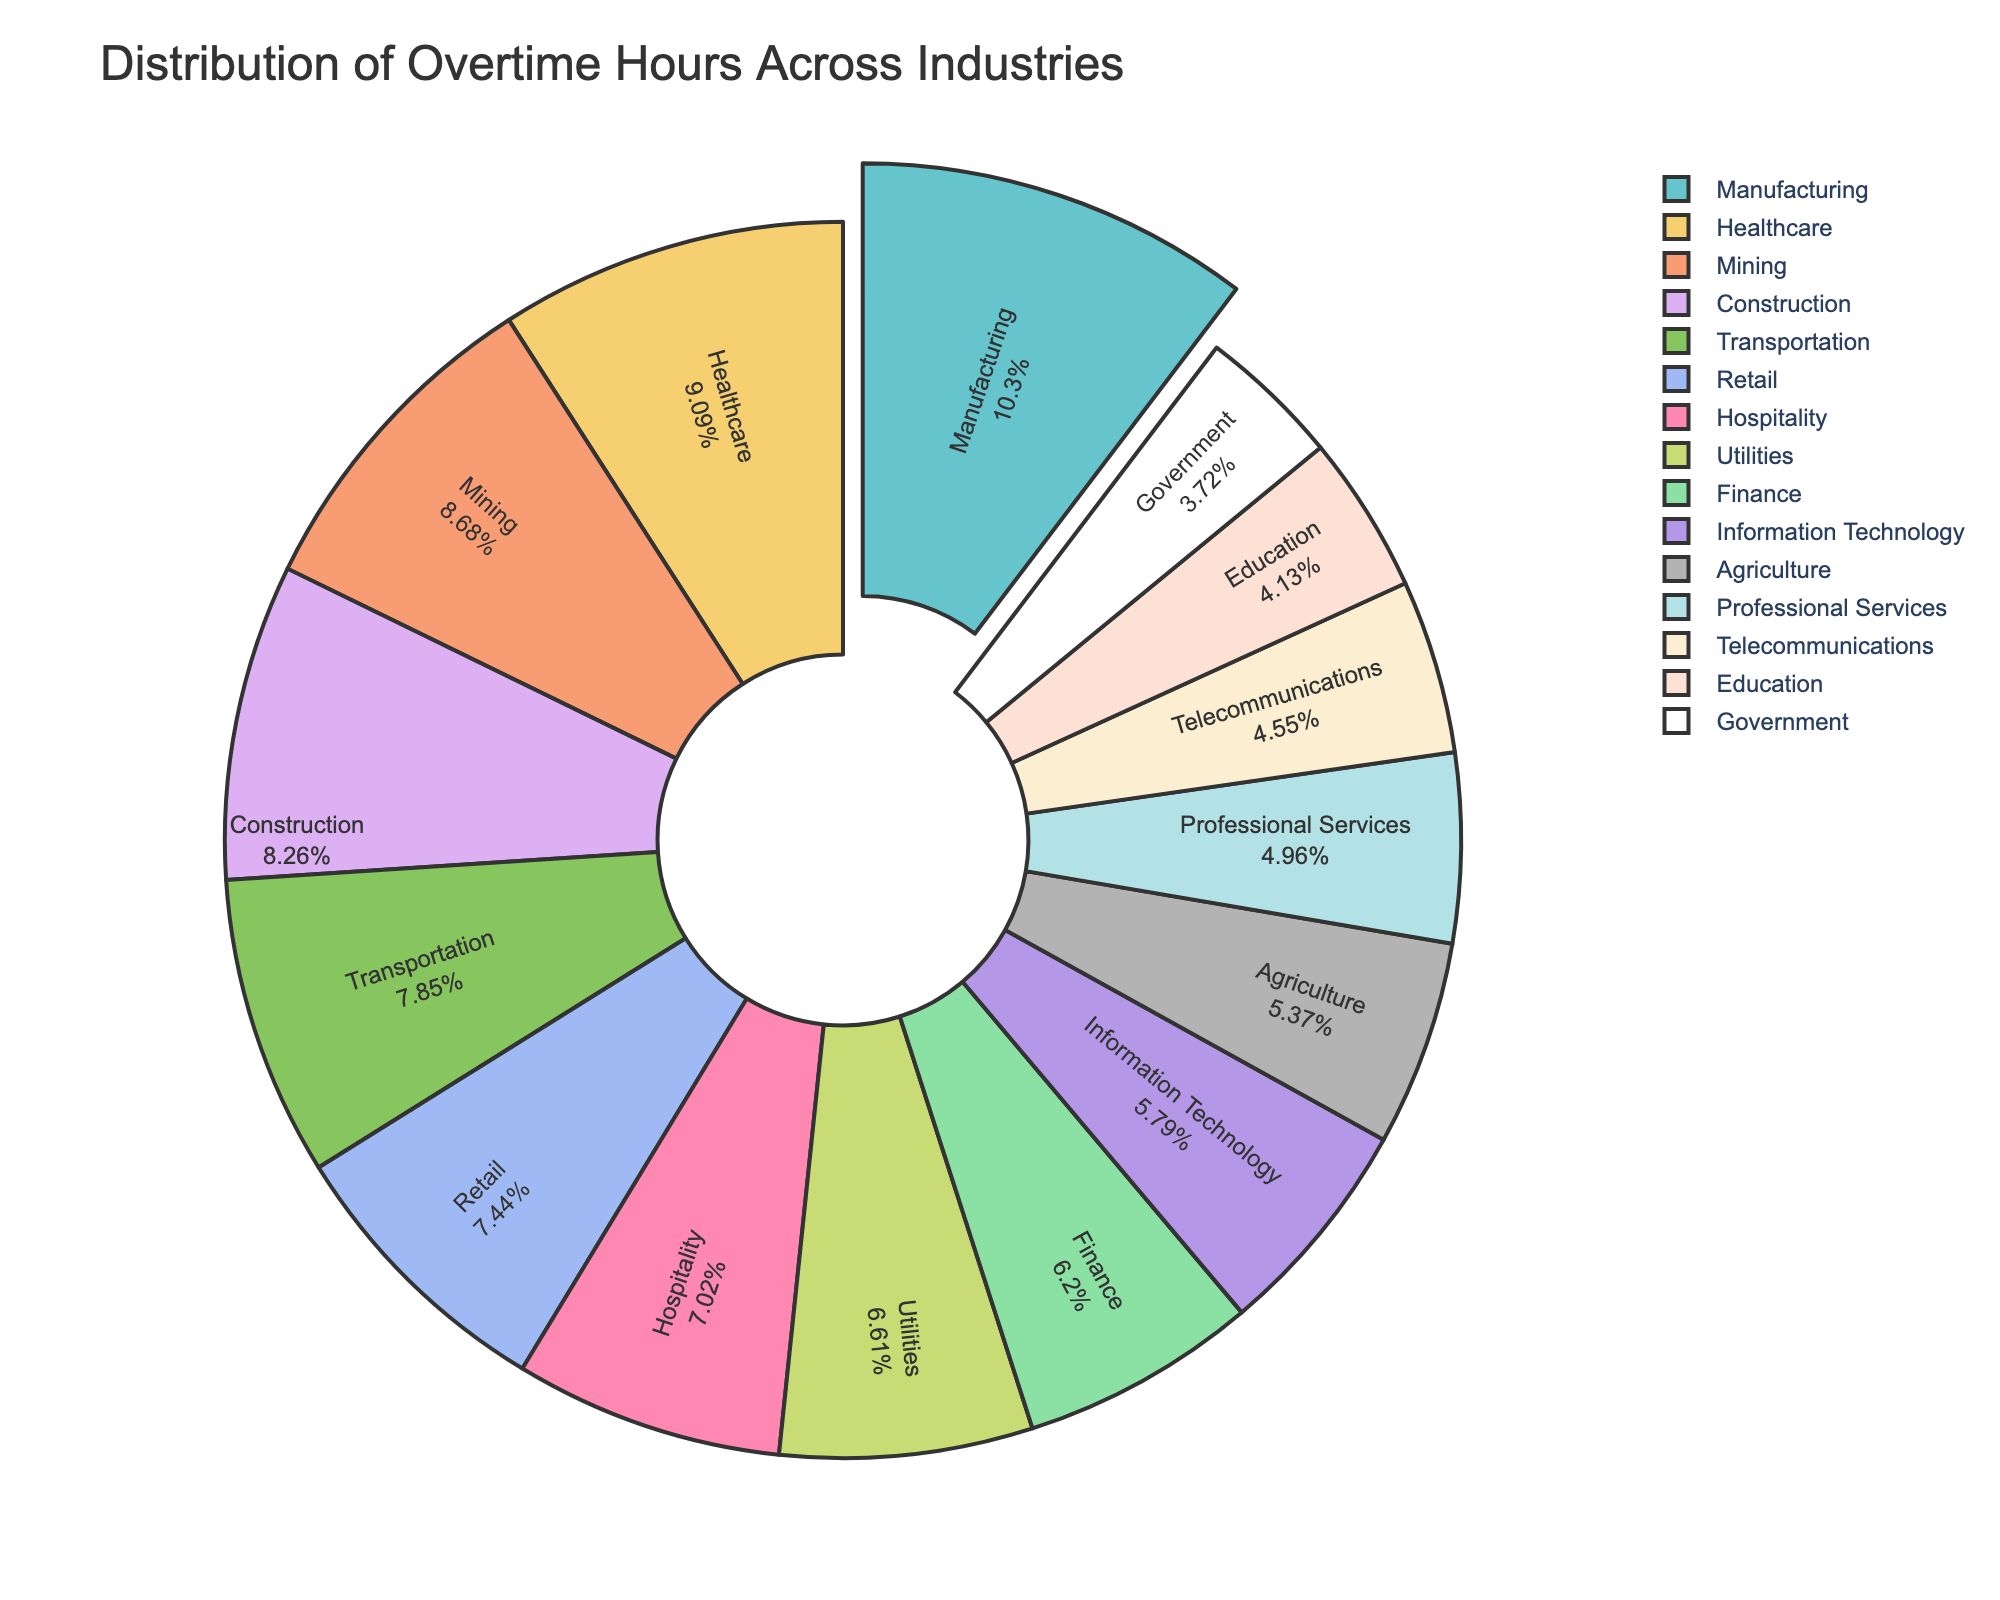Which industry has the highest percentage of overtime hours? The Manufacturing industry has the highest percentage of overtime hours. This is depicted by the slice being pulled out of the pie chart, an indication of its highest value.
Answer: Manufacturing Which industries have more overtime hours than Construction? Industries with more overtime hours than Construction are Manufacturing and Healthcare, as their slices are larger than the Construction slice in the pie chart.
Answer: Manufacturing, Healthcare What is the combined percentage of overtime hours for Finance, Information Technology, and Professional Services? First, find the percentage of each industry: Finance, Information Technology, and Professional Services slices. Sum their percentages from the pie chart.
Answer: Sum of slices for Finance, Information Technology, and Professional Services Which industry has the smallest percentage of overtime hours? The Government industry has the smallest percentage of overtime hours. This is evident from its smallest slice in the pie chart.
Answer: Government What visual features highlight the industry with the most overtime hours? The largest slice is pulled out of the pie chart, labeled "Manufacturing" with a high percentage written inside it, signaling its dominance.
Answer: Largest slice, pulled out, contains highest percentage How many industries have a percentage of total overtime hours between 10% and 15%? Identify slices labeled within the 10% to 15% range. These industries are Retail, Construction, Information Technology, Hospitality, Professional Services, Utilities, Mining, and Agriculture. Count these slices.
Answer: 8 What's the difference in percentage between the industry with the highest and the industry with the smallest overtime hours? Subtract the percentage of the smallest slice (Government) from the largest slice (Manufacturing).
Answer: Percentage difference between Manufacturing and Government Which industry has slightly fewer overtime hours than Transportation? Hospitality has slightly fewer overtime hours than Transportation, as indicated by its close-sized but slightly smaller slice just adjacent to Transportation.
Answer: Hospitality Is the percentage of overtime hours for the Education industry greater or smaller than Utilities? Compare the size of the Education industry slice with the Utilities slice. Since Education is smaller, it has fewer overtime hours.
Answer: Smaller What is the median overtime hour value across all industries? List overtime hours: 25, 22, 21, 20, 19, 18, 17, 16, 15, 14, 13, 12, 11, 10, 9. Median is the middle value. The ordered list of values tells us the median is 16.
Answer: 16 